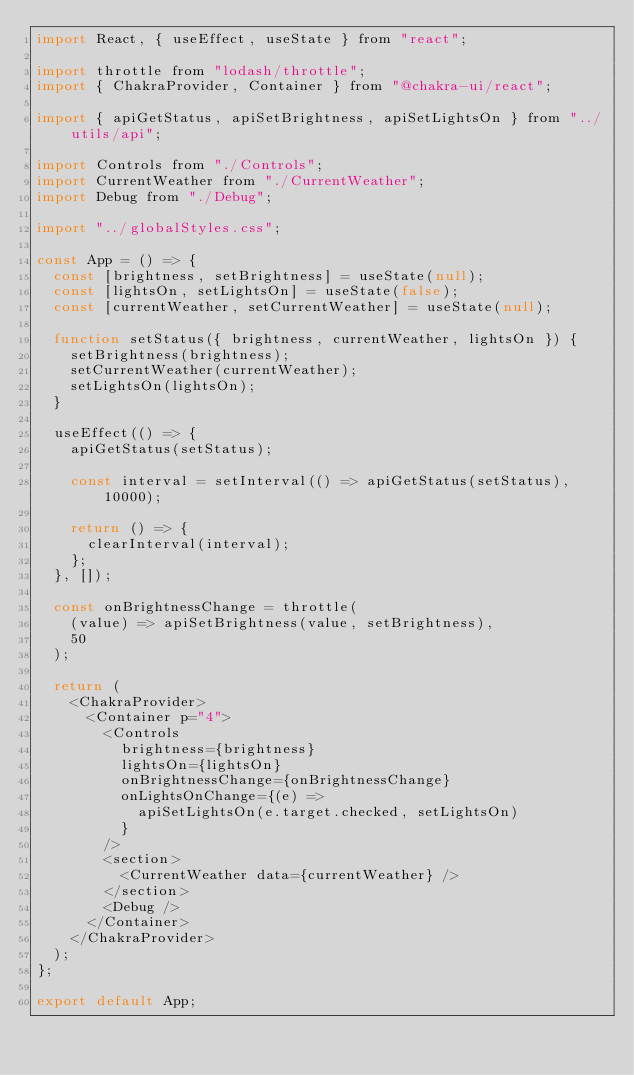Convert code to text. <code><loc_0><loc_0><loc_500><loc_500><_JavaScript_>import React, { useEffect, useState } from "react";

import throttle from "lodash/throttle";
import { ChakraProvider, Container } from "@chakra-ui/react";

import { apiGetStatus, apiSetBrightness, apiSetLightsOn } from "../utils/api";

import Controls from "./Controls";
import CurrentWeather from "./CurrentWeather";
import Debug from "./Debug";

import "../globalStyles.css";

const App = () => {
  const [brightness, setBrightness] = useState(null);
  const [lightsOn, setLightsOn] = useState(false);
  const [currentWeather, setCurrentWeather] = useState(null);

  function setStatus({ brightness, currentWeather, lightsOn }) {
    setBrightness(brightness);
    setCurrentWeather(currentWeather);
    setLightsOn(lightsOn);
  }

  useEffect(() => {
    apiGetStatus(setStatus);

    const interval = setInterval(() => apiGetStatus(setStatus), 10000);

    return () => {
      clearInterval(interval);
    };
  }, []);

  const onBrightnessChange = throttle(
    (value) => apiSetBrightness(value, setBrightness),
    50
  );

  return (
    <ChakraProvider>
      <Container p="4">
        <Controls
          brightness={brightness}
          lightsOn={lightsOn}
          onBrightnessChange={onBrightnessChange}
          onLightsOnChange={(e) =>
            apiSetLightsOn(e.target.checked, setLightsOn)
          }
        />
        <section>
          <CurrentWeather data={currentWeather} />
        </section>
        <Debug />
      </Container>
    </ChakraProvider>
  );
};

export default App;
</code> 